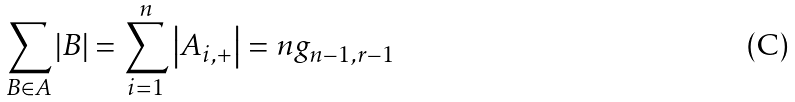Convert formula to latex. <formula><loc_0><loc_0><loc_500><loc_500>\sum _ { B \in A } \left | B \right | = \sum _ { i = 1 } ^ { n } \left | A _ { i , + } \right | = n g _ { n - 1 , r - 1 }</formula> 